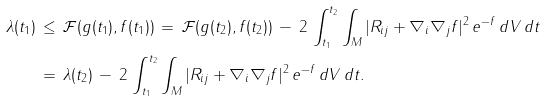<formula> <loc_0><loc_0><loc_500><loc_500>\lambda ( t _ { 1 } ) \, & \leq \, { \mathcal { F } } ( g ( t _ { 1 } ) , f ( t _ { 1 } ) ) \, = \, { \mathcal { F } } ( g ( t _ { 2 } ) , f ( t _ { 2 } ) ) \, - \, 2 \, \int _ { t _ { 1 } } ^ { t _ { 2 } } \int _ { M } | R _ { i j } + \nabla _ { i } \nabla _ { j } f | ^ { 2 } \, e ^ { - f } \, d V \, d t \\ & = \, \lambda ( t _ { 2 } ) \, - \, 2 \, \int _ { t _ { 1 } } ^ { t _ { 2 } } \int _ { M } | R _ { i j } + \nabla _ { i } \nabla _ { j } f | ^ { 2 } \, e ^ { - f } \, d V \, d t .</formula> 